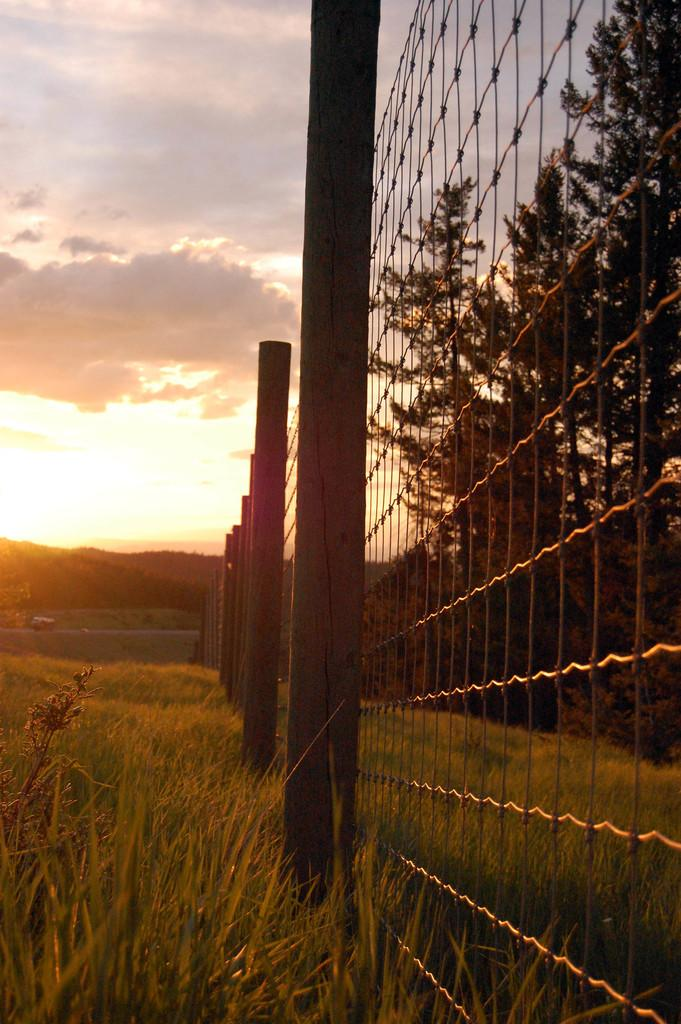What type of vegetation can be seen at the bottom of the image? There are crops at the bottom of the image. What separates the crops from another area in the image? There is a fence between the crops. What is visible at the top of the image? The sky is visible at the top of the image. What type of plant is on the right side of the image? There is a tree on the right side of the image. What celestial body is on the left side of the image? There is a sun on the left side of the image. What type of cloth is being used to dam the river in the image? There is no river or cloth present in the image. What is the need for the sun to be shining so brightly in the image? The sun's brightness is not relevant to the image, as it is simply a celestial body in the sky. 